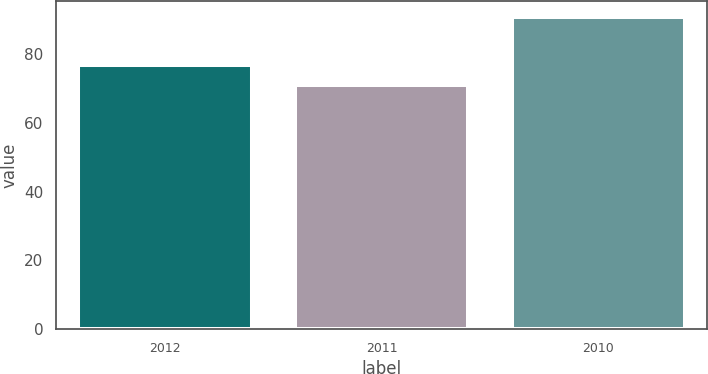<chart> <loc_0><loc_0><loc_500><loc_500><bar_chart><fcel>2012<fcel>2011<fcel>2010<nl><fcel>77<fcel>71<fcel>91<nl></chart> 